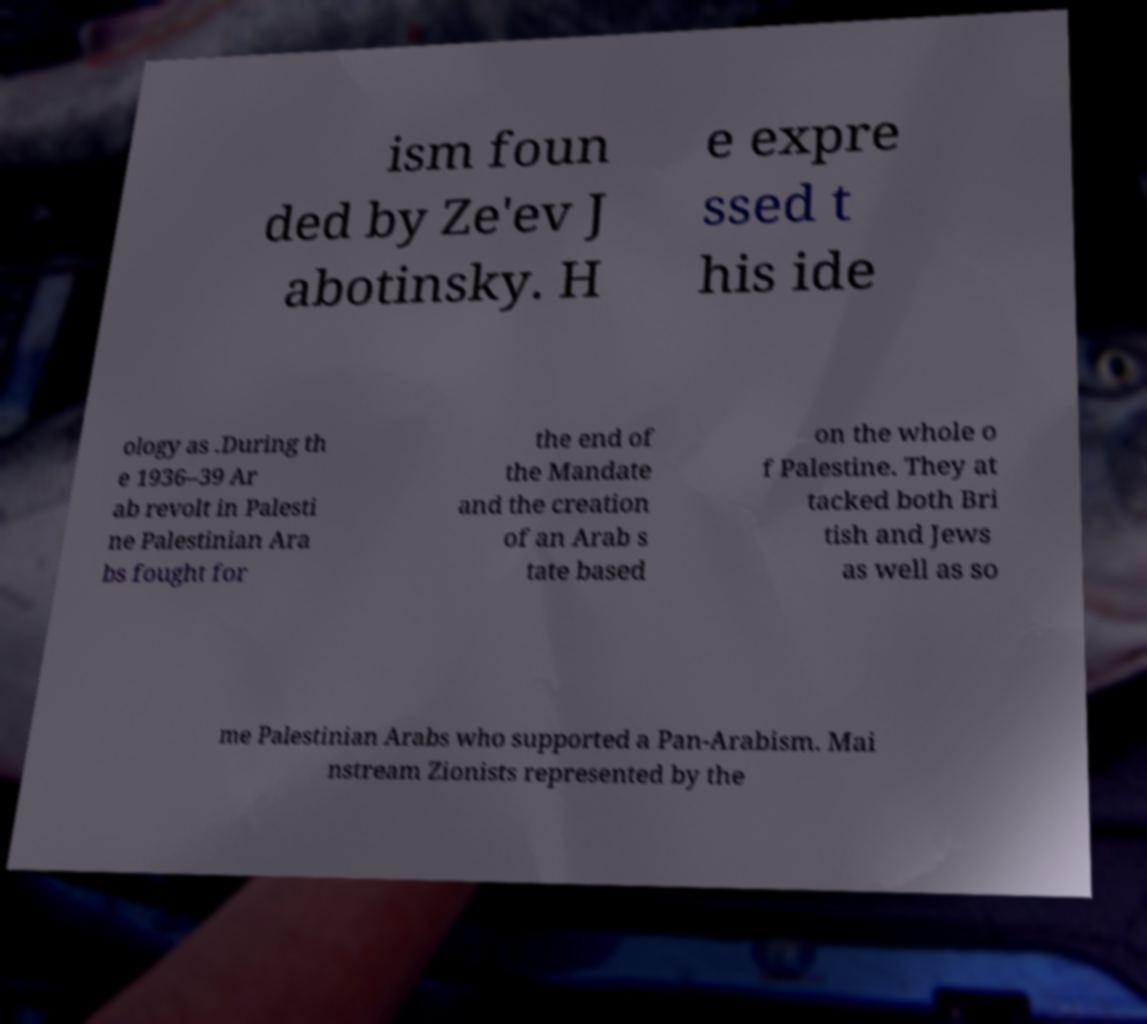Could you assist in decoding the text presented in this image and type it out clearly? ism foun ded by Ze'ev J abotinsky. H e expre ssed t his ide ology as .During th e 1936–39 Ar ab revolt in Palesti ne Palestinian Ara bs fought for the end of the Mandate and the creation of an Arab s tate based on the whole o f Palestine. They at tacked both Bri tish and Jews as well as so me Palestinian Arabs who supported a Pan-Arabism. Mai nstream Zionists represented by the 